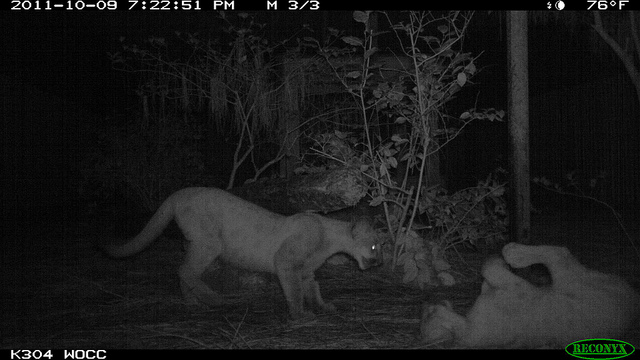Identify and read out the text in this image. 2011 10 09 7 22 51 PM M 3 K304 WOCC BECONYX 76&#176;F 3 